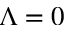Convert formula to latex. <formula><loc_0><loc_0><loc_500><loc_500>\Lambda = 0</formula> 